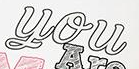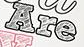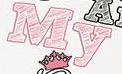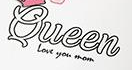What text is displayed in these images sequentially, separated by a semicolon? You; Are; My; Queen 